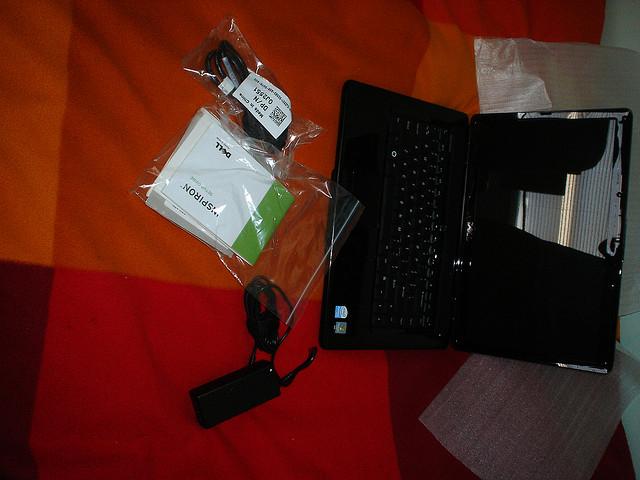Why is everything on the bed?
Answer briefly. Unboxing. What is the picture on the book?
Be succinct. None. Is the computer on?
Concise answer only. No. What brand and model of computer is in the picture?
Be succinct. Dell inspiron. What color is the laptop?
Give a very brief answer. Black. 